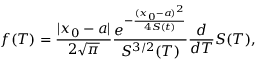<formula> <loc_0><loc_0><loc_500><loc_500>f ( T ) = \frac { | x _ { 0 } - a | } { 2 \sqrt { \pi } } \frac { e ^ { - \frac { ( x _ { 0 } - a ) ^ { 2 } } { 4 S ( t ) } } } { S ^ { 3 / 2 } ( T ) } \frac { d } { d T } S ( T ) ,</formula> 